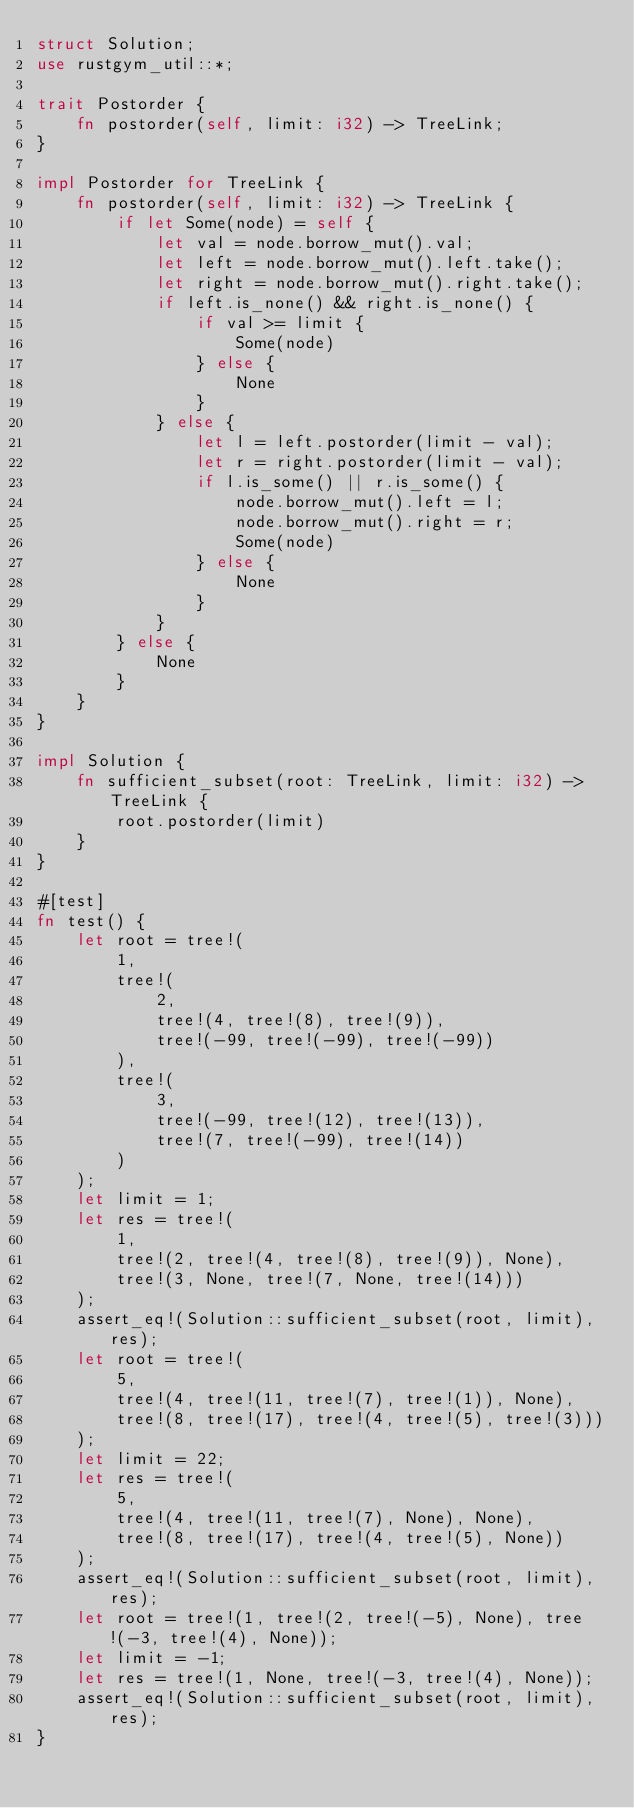<code> <loc_0><loc_0><loc_500><loc_500><_Rust_>struct Solution;
use rustgym_util::*;

trait Postorder {
    fn postorder(self, limit: i32) -> TreeLink;
}

impl Postorder for TreeLink {
    fn postorder(self, limit: i32) -> TreeLink {
        if let Some(node) = self {
            let val = node.borrow_mut().val;
            let left = node.borrow_mut().left.take();
            let right = node.borrow_mut().right.take();
            if left.is_none() && right.is_none() {
                if val >= limit {
                    Some(node)
                } else {
                    None
                }
            } else {
                let l = left.postorder(limit - val);
                let r = right.postorder(limit - val);
                if l.is_some() || r.is_some() {
                    node.borrow_mut().left = l;
                    node.borrow_mut().right = r;
                    Some(node)
                } else {
                    None
                }
            }
        } else {
            None
        }
    }
}

impl Solution {
    fn sufficient_subset(root: TreeLink, limit: i32) -> TreeLink {
        root.postorder(limit)
    }
}

#[test]
fn test() {
    let root = tree!(
        1,
        tree!(
            2,
            tree!(4, tree!(8), tree!(9)),
            tree!(-99, tree!(-99), tree!(-99))
        ),
        tree!(
            3,
            tree!(-99, tree!(12), tree!(13)),
            tree!(7, tree!(-99), tree!(14))
        )
    );
    let limit = 1;
    let res = tree!(
        1,
        tree!(2, tree!(4, tree!(8), tree!(9)), None),
        tree!(3, None, tree!(7, None, tree!(14)))
    );
    assert_eq!(Solution::sufficient_subset(root, limit), res);
    let root = tree!(
        5,
        tree!(4, tree!(11, tree!(7), tree!(1)), None),
        tree!(8, tree!(17), tree!(4, tree!(5), tree!(3)))
    );
    let limit = 22;
    let res = tree!(
        5,
        tree!(4, tree!(11, tree!(7), None), None),
        tree!(8, tree!(17), tree!(4, tree!(5), None))
    );
    assert_eq!(Solution::sufficient_subset(root, limit), res);
    let root = tree!(1, tree!(2, tree!(-5), None), tree!(-3, tree!(4), None));
    let limit = -1;
    let res = tree!(1, None, tree!(-3, tree!(4), None));
    assert_eq!(Solution::sufficient_subset(root, limit), res);
}
</code> 